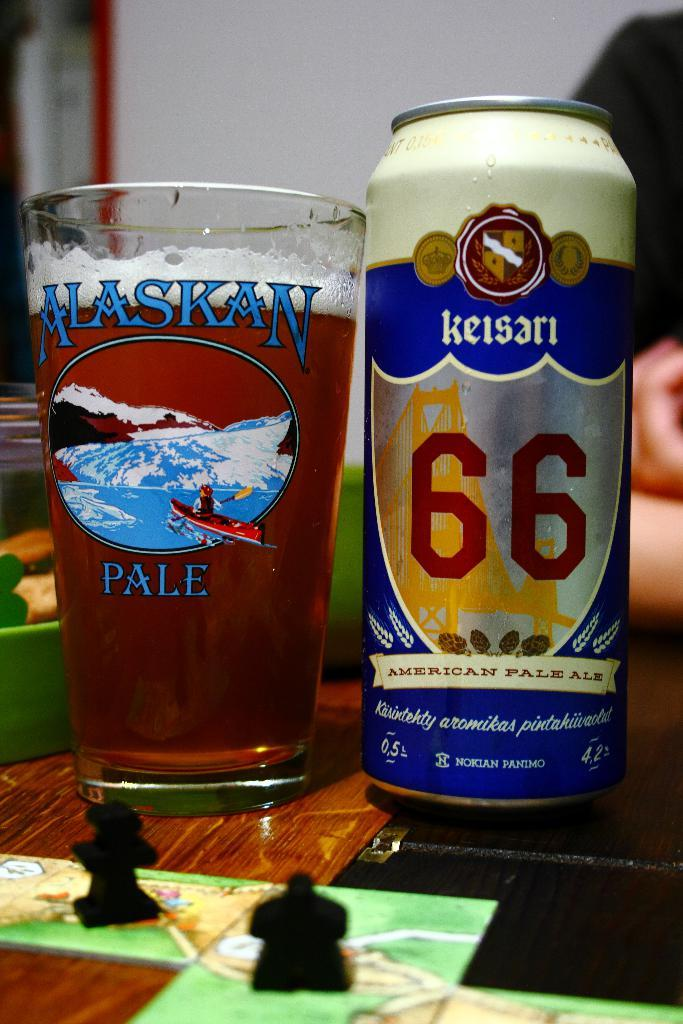<image>
Relay a brief, clear account of the picture shown. A glass marked Alaskan Ale sits on a table next to a can of Keisari 66. 